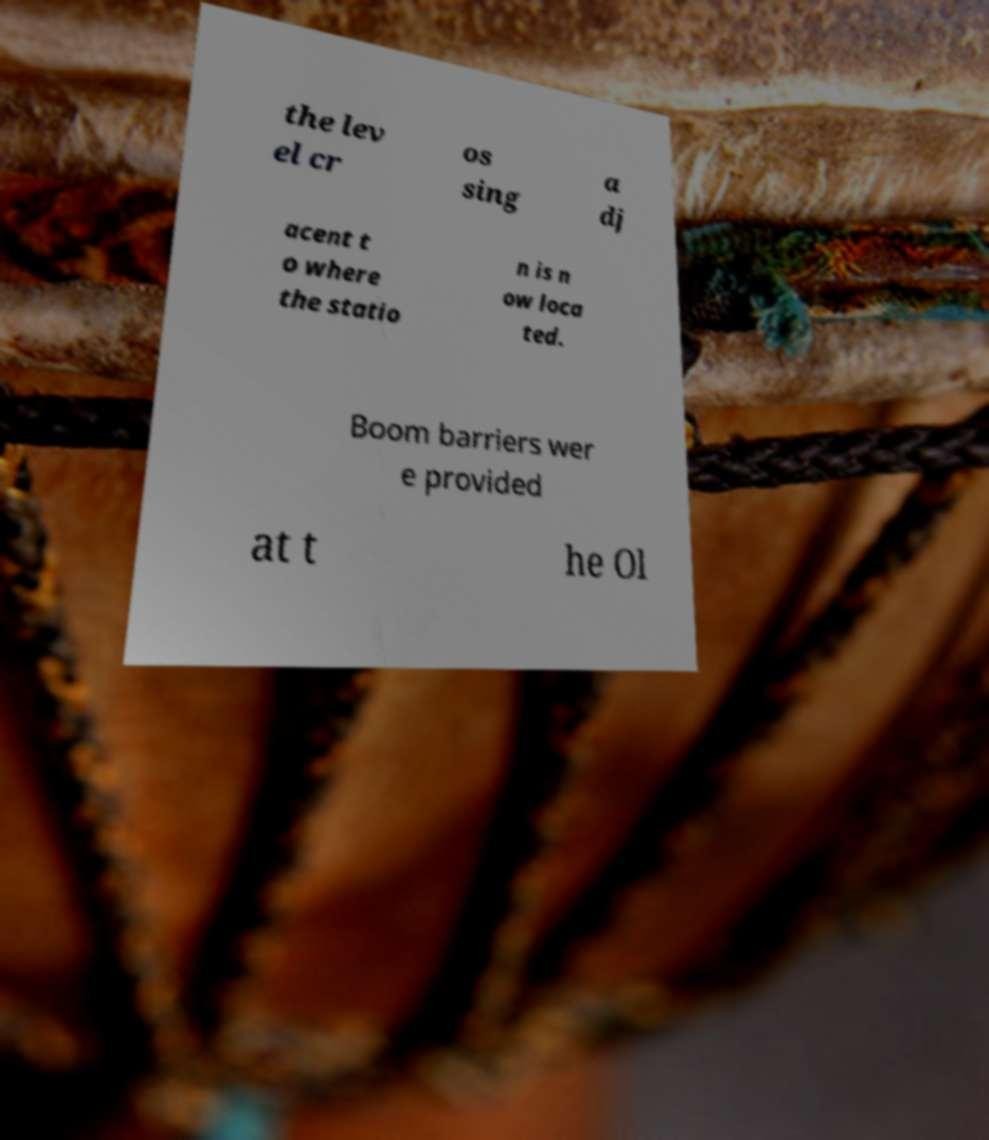I need the written content from this picture converted into text. Can you do that? the lev el cr os sing a dj acent t o where the statio n is n ow loca ted. Boom barriers wer e provided at t he Ol 